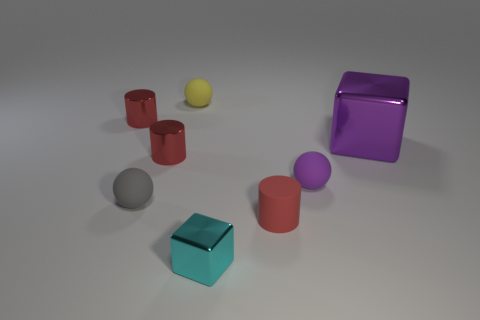What material is the small gray object?
Your answer should be very brief. Rubber. The tiny shiny thing that is to the right of the small yellow ball is what color?
Ensure brevity in your answer.  Cyan. What number of tiny rubber balls have the same color as the large shiny cube?
Make the answer very short. 1. How many objects are both behind the small gray rubber thing and to the left of the big purple shiny object?
Your response must be concise. 4. There is a purple rubber object that is the same size as the cyan block; what shape is it?
Provide a succinct answer. Sphere. What size is the purple metallic object?
Offer a very short reply. Large. What material is the purple thing behind the sphere that is to the right of the cylinder that is on the right side of the yellow object made of?
Your answer should be very brief. Metal. There is a large thing that is the same material as the tiny cyan object; what color is it?
Your answer should be very brief. Purple. There is a red shiny thing that is behind the large purple object behind the tiny gray matte object; how many purple shiny blocks are behind it?
Your answer should be compact. 0. There is a tiny sphere that is the same color as the large thing; what material is it?
Provide a short and direct response. Rubber. 